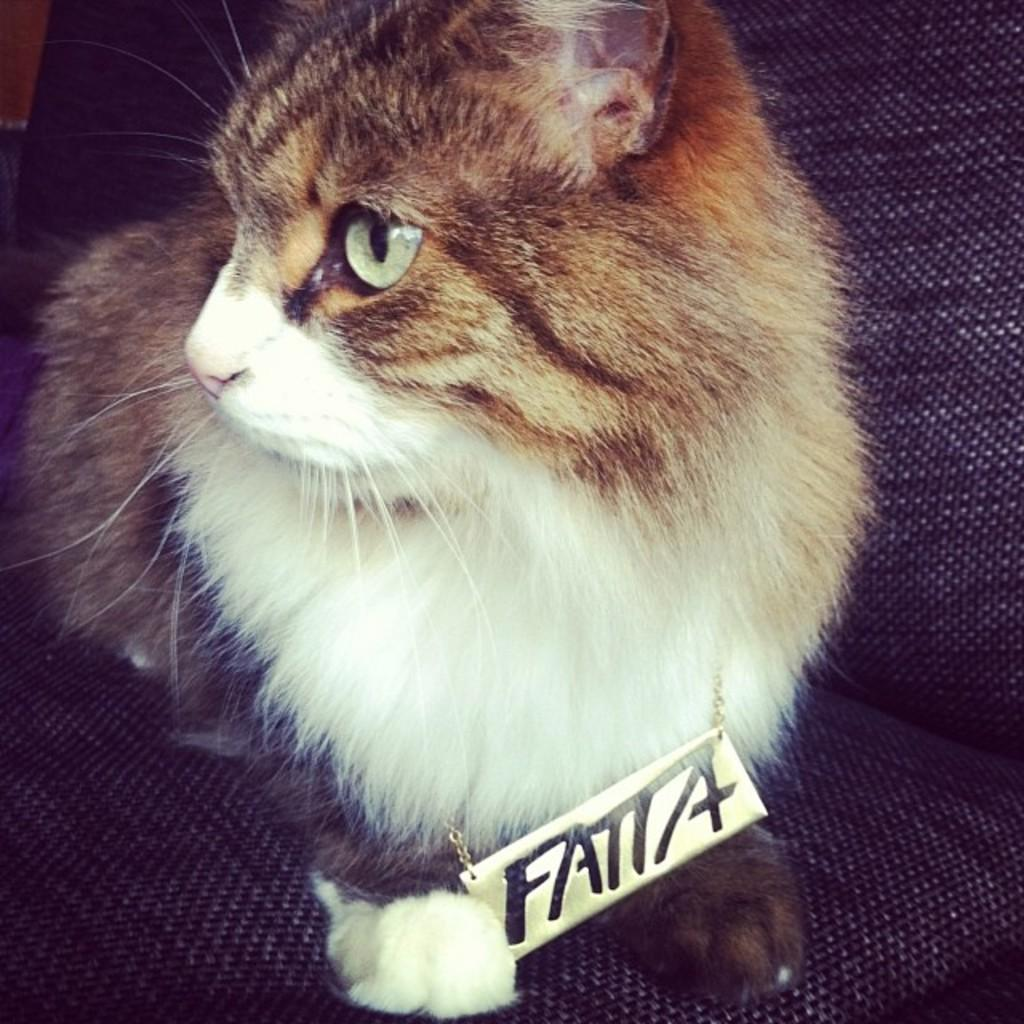What is the main subject in the foreground of the picture? There is a cat in the foreground of the picture. What is the cat doing in the picture? The cat is sitting on a chair. Can you describe any accessories the cat is wearing? The cat has a locket named "FATTA" around its neck. How many kittens can be seen playing with the cat's nose in the image? There are no kittens visible in the image, and the cat's nose is not mentioned in the provided facts. 